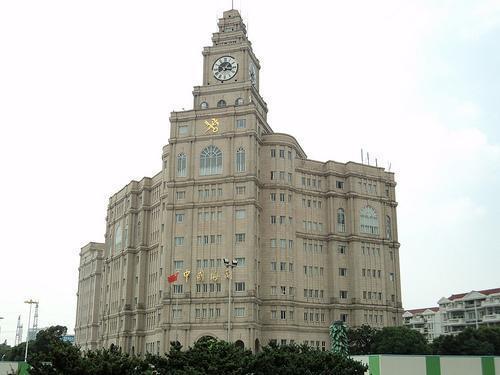How many clocks?
Give a very brief answer. 1. 